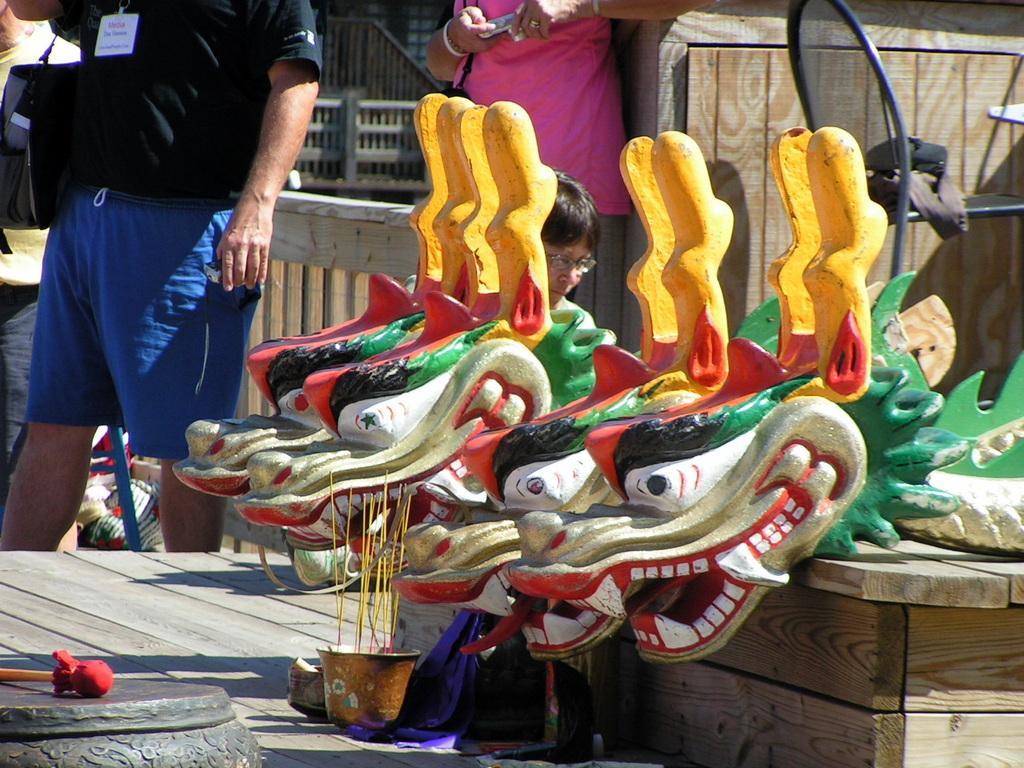Describe this image in one or two sentences. In this image I can see a person standing wearing black shirt, blue short. At right I can see few objects they are in black, green, red and white color. At back I can see the other person standing wearing pink shirt holding camera. 